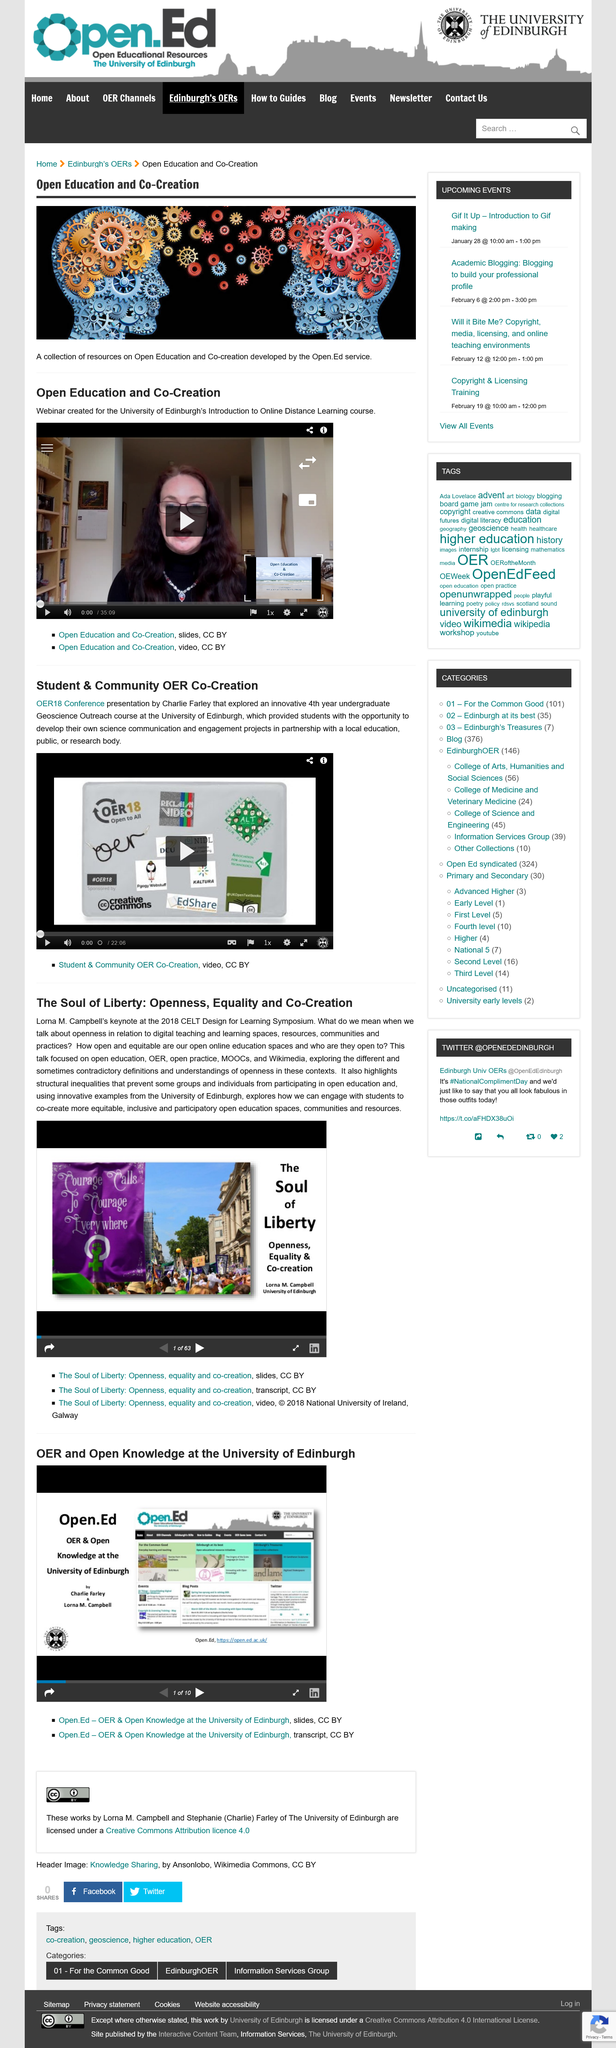Give some essential details in this illustration. The Open Education service developed a collection of resources on Open Education and Co-Creation, as stated in the article "Open Education and Co-Creation. Lorna M. Campbell gave a keynote at the CELT Design for Learning Symposium in 2018. The webinar was created for the University of Edinburgh's introduction to Online Distance Learning course, where it was used to introduce the topic of communication in online learning. Lorna M. Campbell delivered a keynote speech at the CELT Design for Learning Symposium in 2018, where she talked about a university. She supported her points with numerous examples from the University of Edinburgh. Lorna M. Campbell delivered a keynote speech at the CELT Design for Learning Symposium in 2018, titled "The Soul of Liberty: Openness, Equality, and Co-Creation. 